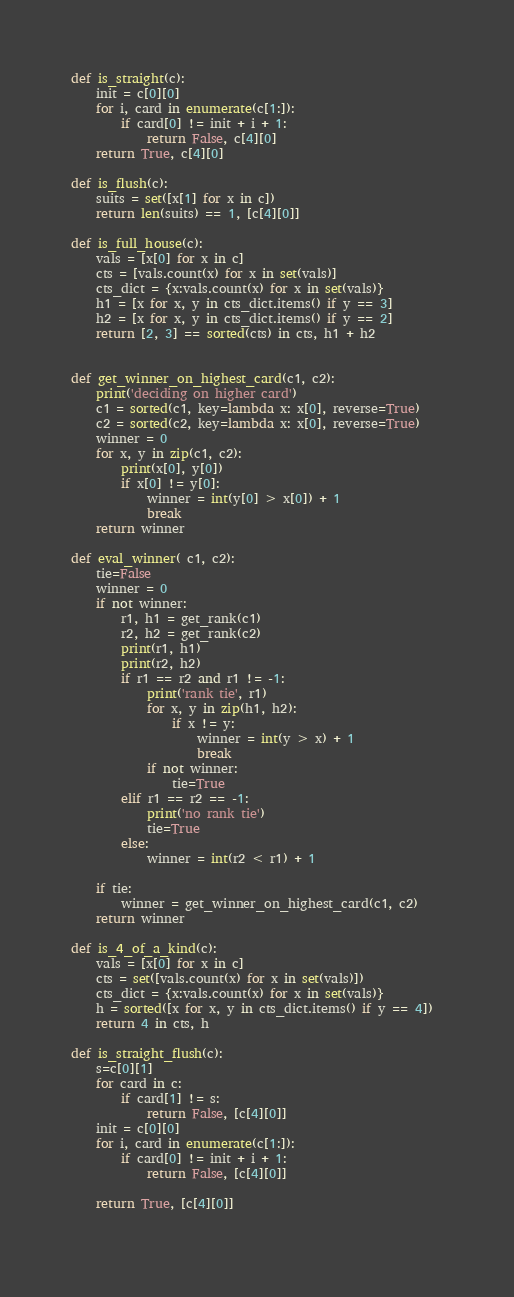Convert code to text. <code><loc_0><loc_0><loc_500><loc_500><_Python_>def is_straight(c):
	init = c[0][0]
	for i, card in enumerate(c[1:]):
		if card[0] != init + i + 1:
			return False, c[4][0]
	return True, c[4][0]
	
def is_flush(c):
	suits = set([x[1] for x in c])
	return len(suits) == 1, [c[4][0]]
	
def is_full_house(c):
	vals = [x[0] for x in c]
	cts = [vals.count(x) for x in set(vals)]
	cts_dict = {x:vals.count(x) for x in set(vals)}
	h1 = [x for x, y in cts_dict.items() if y == 3]
	h2 = [x for x, y in cts_dict.items() if y == 2]
	return [2, 3] == sorted(cts) in cts, h1 + h2
	
	
def get_winner_on_highest_card(c1, c2):
	print('deciding on higher card')
	c1 = sorted(c1, key=lambda x: x[0], reverse=True)
	c2 = sorted(c2, key=lambda x: x[0], reverse=True)
	winner = 0
	for x, y in zip(c1, c2):
		print(x[0], y[0])
		if x[0] != y[0]:
			winner = int(y[0] > x[0]) + 1
			break
	return winner
				
def eval_winner( c1, c2):
	tie=False
	winner = 0
	if not winner:
		r1, h1 = get_rank(c1)
		r2, h2 = get_rank(c2)
		print(r1, h1)
		print(r2, h2)
		if r1 == r2 and r1 != -1:
			print('rank tie', r1)
			for x, y in zip(h1, h2):
				if x != y:
					winner = int(y > x) + 1
					break
			if not winner:
				tie=True
		elif r1 == r2 == -1:
			print('no rank tie')
			tie=True
		else:
			winner = int(r2 < r1) + 1
		
	if tie:
		winner = get_winner_on_highest_card(c1, c2)	
	return winner

def is_4_of_a_kind(c):
	vals = [x[0] for x in c]
	cts = set([vals.count(x) for x in set(vals)])
	cts_dict = {x:vals.count(x) for x in set(vals)}
	h = sorted([x for x, y in cts_dict.items() if y == 4])
	return 4 in cts, h
	
def is_straight_flush(c):
	s=c[0][1]
	for card in c:
		if card[1] != s:
			return False, [c[4][0]]
	init = c[0][0]
	for i, card in enumerate(c[1:]):
		if card[0] != init + i + 1:
			return False, [c[4][0]]
			
	return True, [c[4][0]]
	</code> 